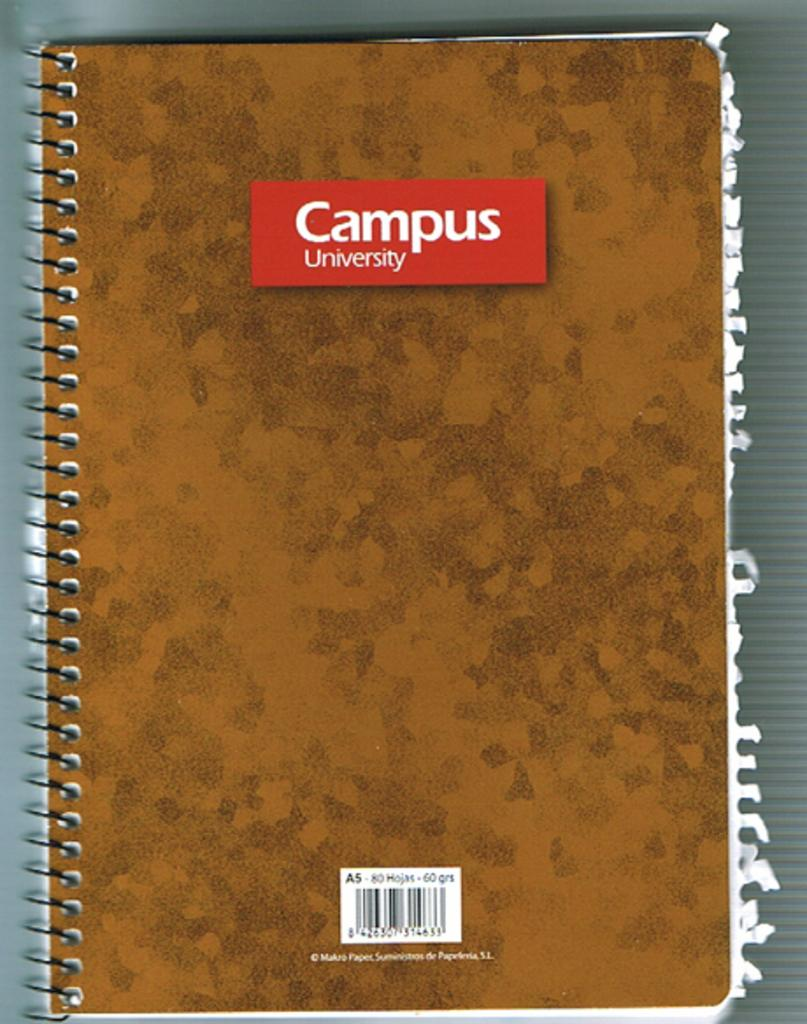What object can be seen in the image? There is a book in the image. Where is the book located? The book is placed on a table. What type of owl can be seen sitting on the book in the image? There is no owl present in the image; it only features a book placed on a table. 